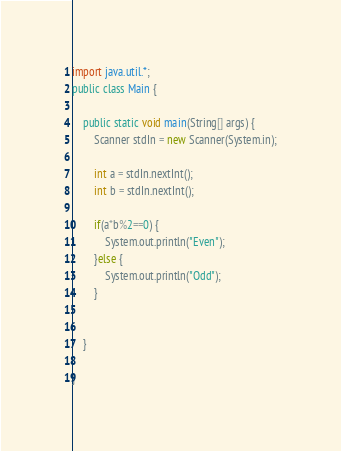Convert code to text. <code><loc_0><loc_0><loc_500><loc_500><_Java_>import java.util.*;
public class Main {

	public static void main(String[] args) {
		Scanner stdIn = new Scanner(System.in);
		
		int a = stdIn.nextInt();
		int b = stdIn.nextInt();
		
		if(a*b%2==0) {
			System.out.println("Even");
		}else {
			System.out.println("Odd");
		}
		
		
	}

}
</code> 